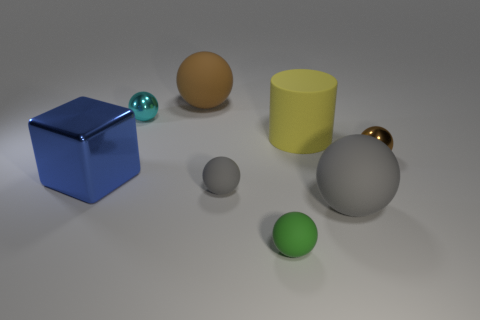Is there a purple cylinder?
Your response must be concise. No. What is the color of the cylinder that is the same size as the blue shiny object?
Give a very brief answer. Yellow. What number of other large rubber objects are the same shape as the large yellow matte object?
Make the answer very short. 0. Is the thing that is behind the tiny cyan thing made of the same material as the big block?
Ensure brevity in your answer.  No. How many cylinders are yellow objects or big gray things?
Provide a succinct answer. 1. What is the shape of the tiny metal thing on the right side of the small green matte sphere that is to the left of the shiny sphere in front of the large cylinder?
Keep it short and to the point. Sphere. How many matte objects are the same size as the blue cube?
Make the answer very short. 3. Are there any small gray matte spheres on the left side of the blue object that is to the left of the big brown sphere?
Ensure brevity in your answer.  No. How many objects are either gray matte balls or large balls?
Offer a very short reply. 3. What color is the big rubber sphere that is in front of the tiny metal sphere behind the brown object on the right side of the large yellow matte cylinder?
Your answer should be compact. Gray. 